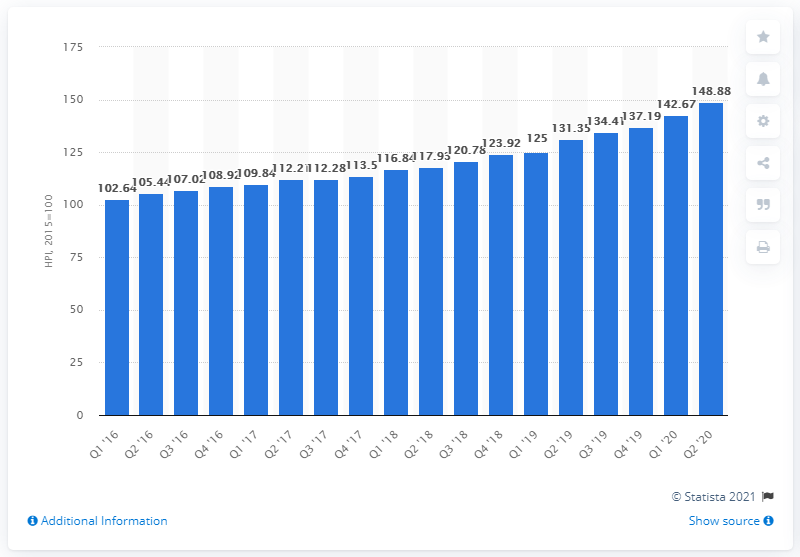Highlight a few significant elements in this photo. In June 2020, the house price index in Luxembourg was 148.88. 